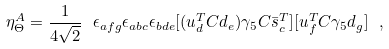Convert formula to latex. <formula><loc_0><loc_0><loc_500><loc_500>\eta ^ { A } _ { \Theta } = \frac { 1 } { 4 \sqrt { 2 } } \ \epsilon _ { a f g } \epsilon _ { a b c } \epsilon _ { b d e } [ ( u ^ { T } _ { d } C d _ { e } ) \gamma _ { 5 } C \bar { s } _ { c } ^ { T } ] [ u ^ { T } _ { f } C \gamma _ { 5 } d _ { g } ] \ ,</formula> 